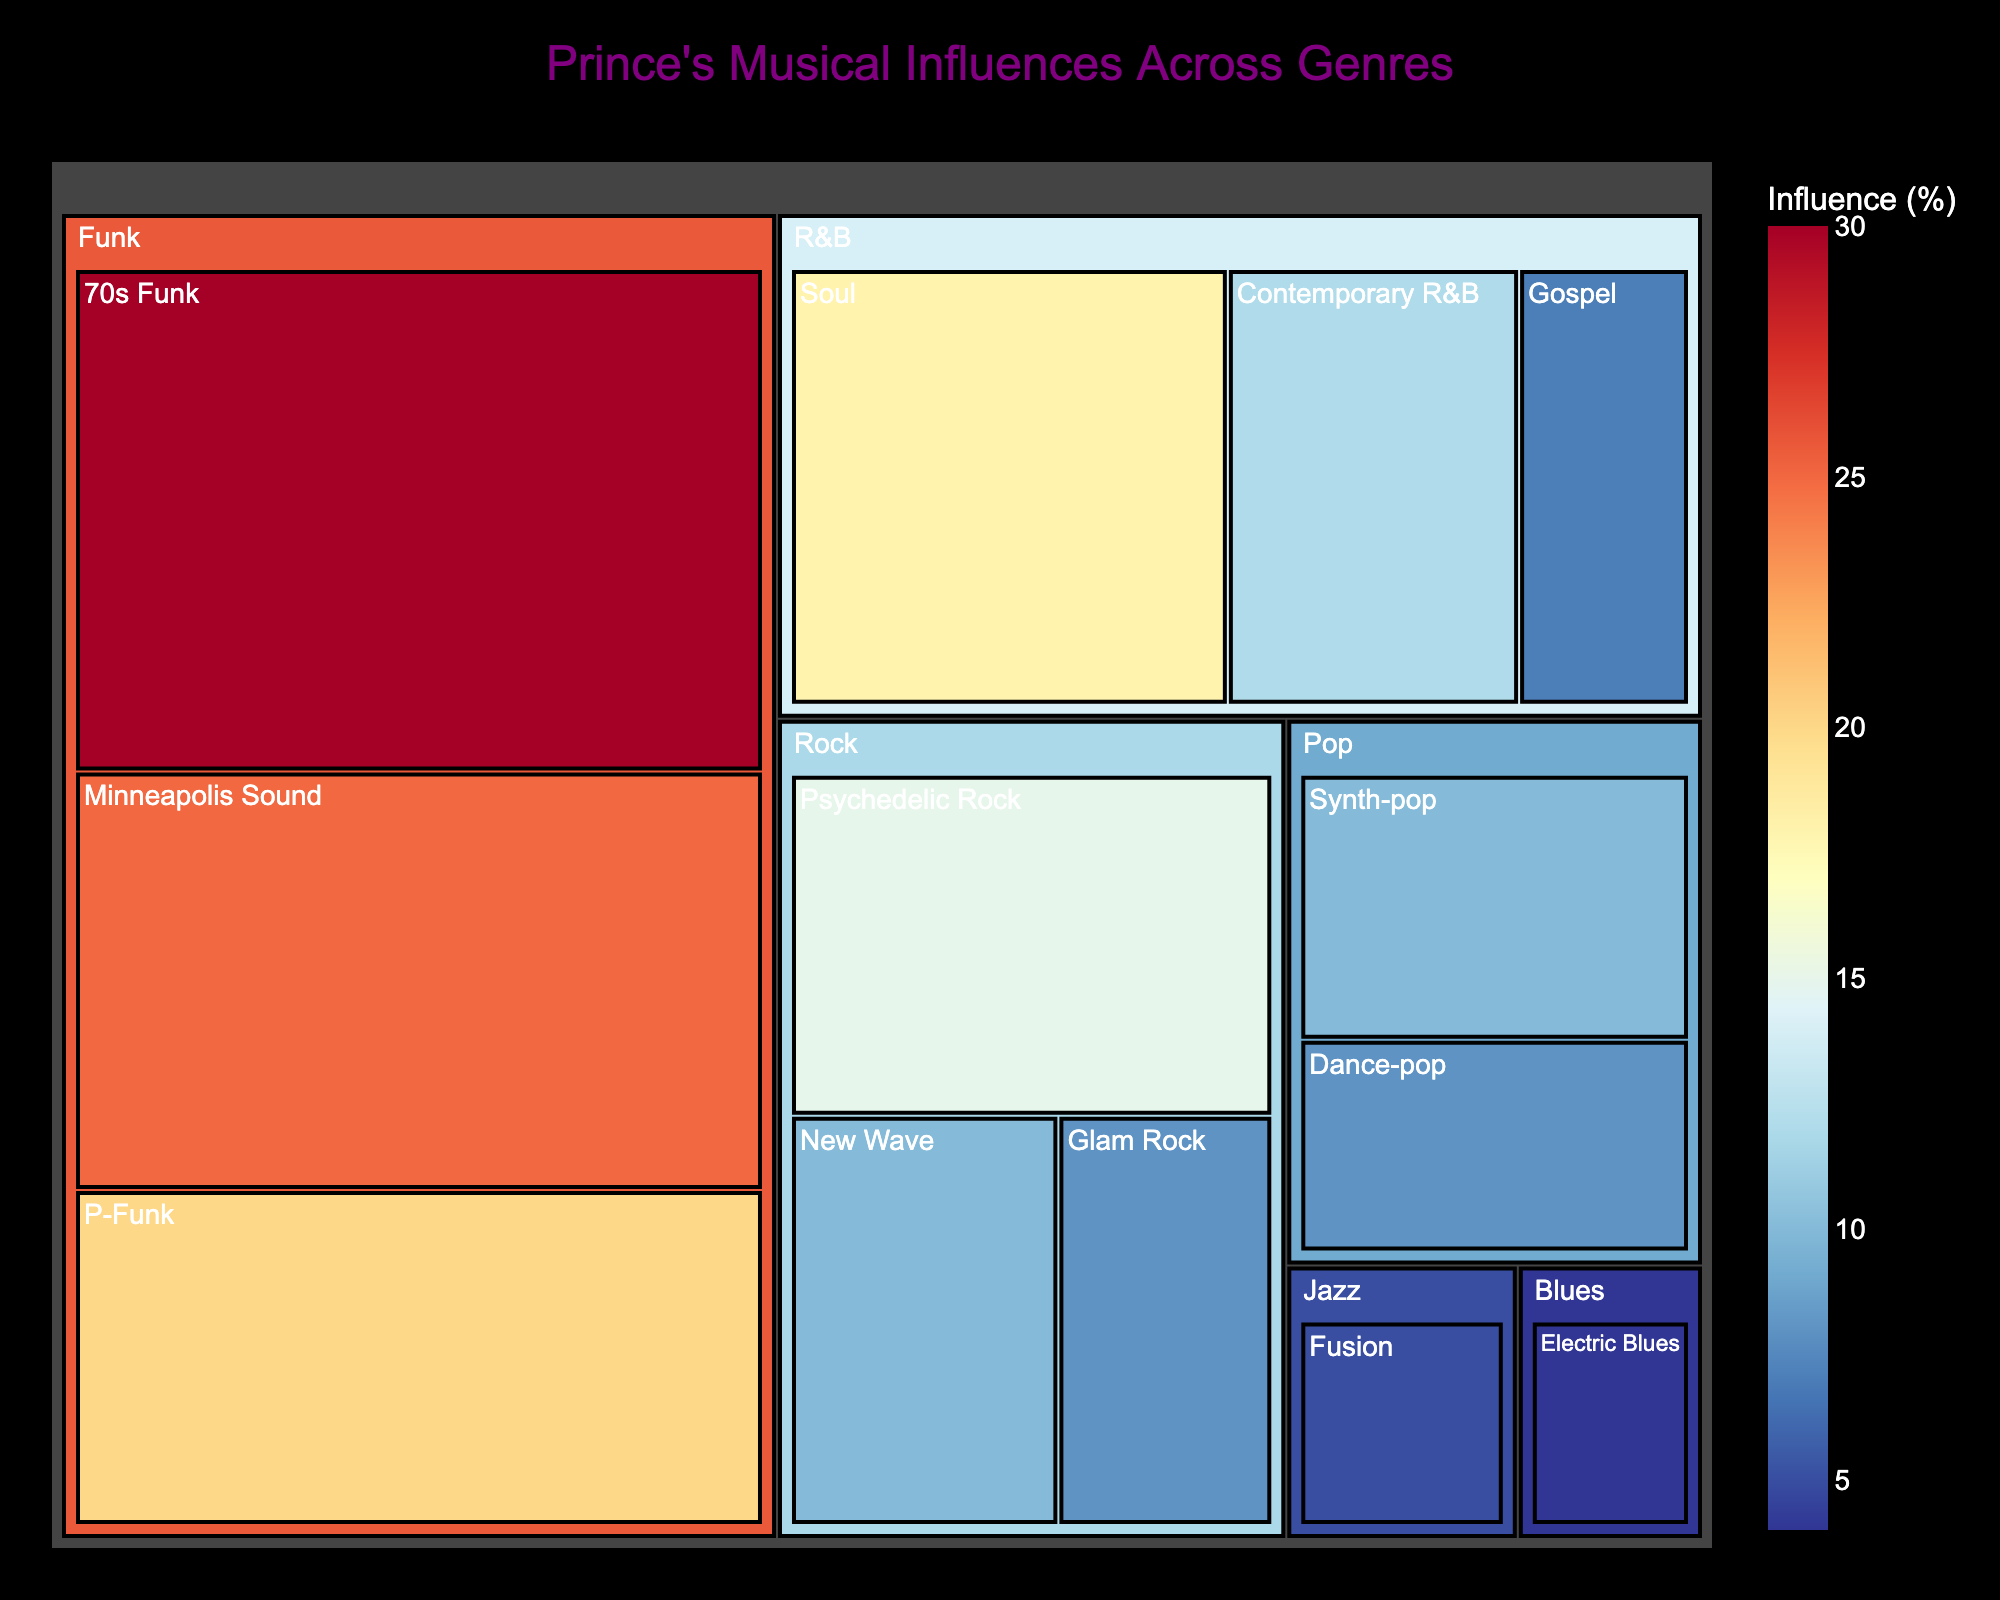What is the title of the treemap? The title is usually placed prominently at the top of the figure, and from the provided code, we know it is specified as "Prince's Musical Influences Across Genres".
Answer: Prince's Musical Influences Across Genres Which genre has the highest overall influence percentage? The treemap visually represents the size of each genre based on their influence values. From the provided data, Funk has the highest total influence, with 75% (30% + 25% + 20%).
Answer: Funk How much influence does the Gospel subgenre have within the R&B genre? We need to locate the Gospel subgenre within the R&B genre on the treemap, and the data shows Gospel has an influence of 7%.
Answer: 7% Compare the combined influence of Rock and Jazz genres. Which one has more influence, and by how much? First, sum the influence values of all subgenres within Rock (15% + 10% + 8% = 33%) and Jazz (5%). The difference is 33% - 5% = 28%. Rock has more influence by 28%.
Answer: Rock, by 28% Which subgenre under the Funk genre has the least influence, and what is its percentage? Within the Funk genre, we compare the influence values of 70s Funk (30%), Minneapolis Sound (25%), and P-Funk (20%). P-Funk has the smallest influence.
Answer: P-Funk, 20% What is the total influence percentage of the Pop genre? Sum the influence percentages of Synth-pop (10%) and Dance-pop (8%). This gives us a total of 18%.
Answer: 18% Which subgenre within the Rock genre has a higher influence: New Wave or Glam Rock? From the data, New Wave has an influence of 10%, while Glam Rock has 8%. Therefore, New Wave has a higher influence.
Answer: New Wave Calculate the average influence percentage of all subgenres in the R&B genre. First, sum the influences of Soul (18%), Contemporary R&B (12%), and Gospel (7%). This gives 37%. The average is 37% / 3 = 12.33%.
Answer: 12.33% What's the influence difference between the Psychedelic Rock subgenre and the Soul subgenre? From the data, Psychedelic Rock has an influence of 15%, and Soul has 18%. The difference is 18% - 15% = 3%.
Answer: 3% How many subgenres does Prince draw influence from in total across all genres? Count all the subgenres listed in the data: 70s Funk, Minneapolis Sound, P-Funk, Psychedelic Rock, New Wave, Glam Rock, Soul, Contemporary R&B, Gospel, Synth-pop, Dance-pop, Fusion, Electric Blues. This totals to 13 subgenres.
Answer: 13 